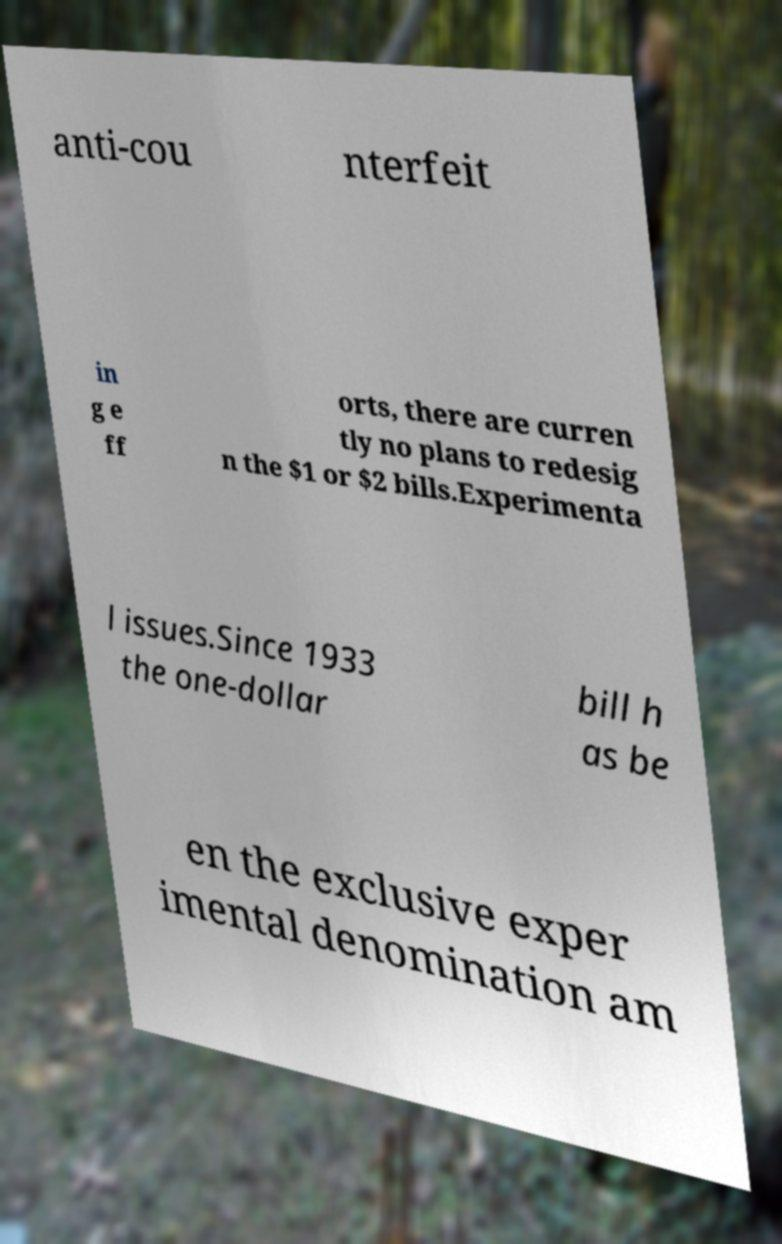Can you read and provide the text displayed in the image?This photo seems to have some interesting text. Can you extract and type it out for me? anti-cou nterfeit in g e ff orts, there are curren tly no plans to redesig n the $1 or $2 bills.Experimenta l issues.Since 1933 the one-dollar bill h as be en the exclusive exper imental denomination am 